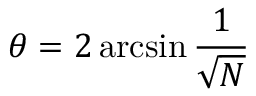Convert formula to latex. <formula><loc_0><loc_0><loc_500><loc_500>\theta = 2 \arcsin { \frac { 1 } { \sqrt { N } } }</formula> 